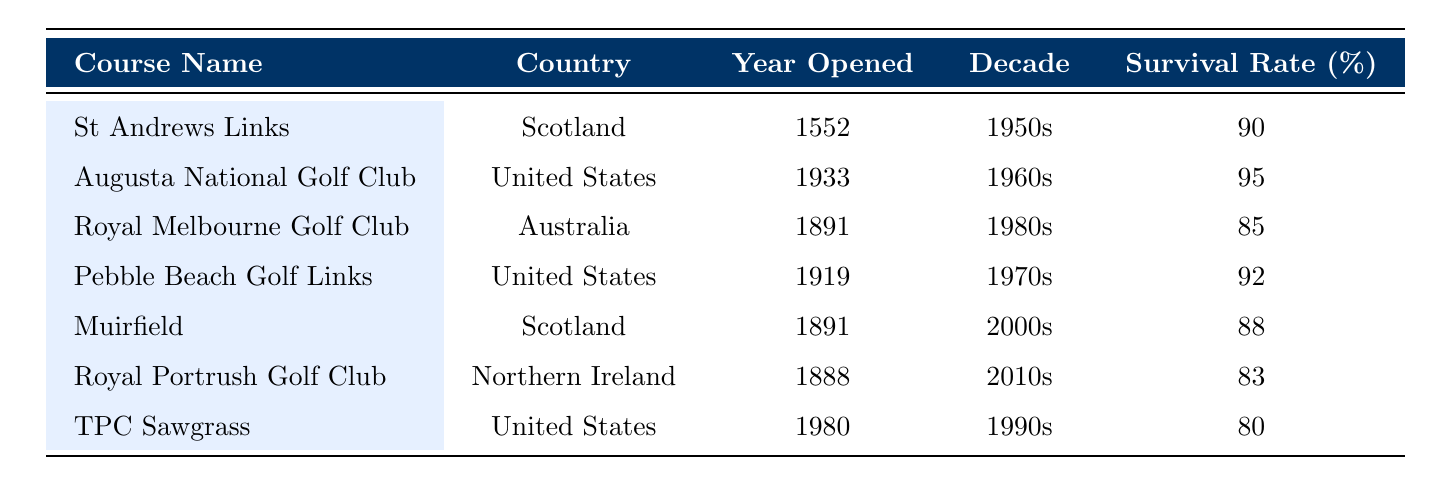What is the survival rate of Pebble Beach Golf Links? According to the table, the survival rate for Pebble Beach Golf Links is listed directly under the relevant column. It shows a survival rate of 92%.
Answer: 92% Which golf course has the highest survival rate? The table includes survival rates for each golf course. By comparing the rates, Augusta National Golf Club has the highest survival rate at 95%.
Answer: 95% How many golf courses in the table were opened before 1900? By examining the "Year Opened" column, St Andrews Links (1552), Royal Melbourne Golf Club (1891), and Royal Portrush Golf Club (1888) were opened before 1900, which totals three courses.
Answer: 3 Is the survival rate of TPC Sawgrass above 85%? Looking at the "Survival Rate" column in the table, TPC Sawgrass has a survival rate of 80%, which is below 85%. Therefore, the statement is false.
Answer: No What is the average survival rate of golf courses from the 2000s? To find the average, we only need to consider the survival rates from the 2000s. The only course from that decade is Muirfield, which has a survival rate of 88%. Since there's only one course, the average is 88%.
Answer: 88 Which country has the golf course with the lowest survival rate? We need to examine the survival rates for each country. The lowest survival rate is 80% for TPC Sawgrass in the United States. Therefore, the United States has the course with the lowest survival rate in this table.
Answer: United States What is the total number of courses listed in the table that are located in Scotland? The table includes two courses from Scotland, which are St Andrews Links and Muirfield. Thus, the total number of courses from Scotland is two.
Answer: 2 Does Royal Melbourne Golf Club have a survival rate less than 90%? According to the table, Royal Melbourne Golf Club has a survival rate of 85%, which is indeed less than 90%. Therefore, the answer is yes.
Answer: Yes 